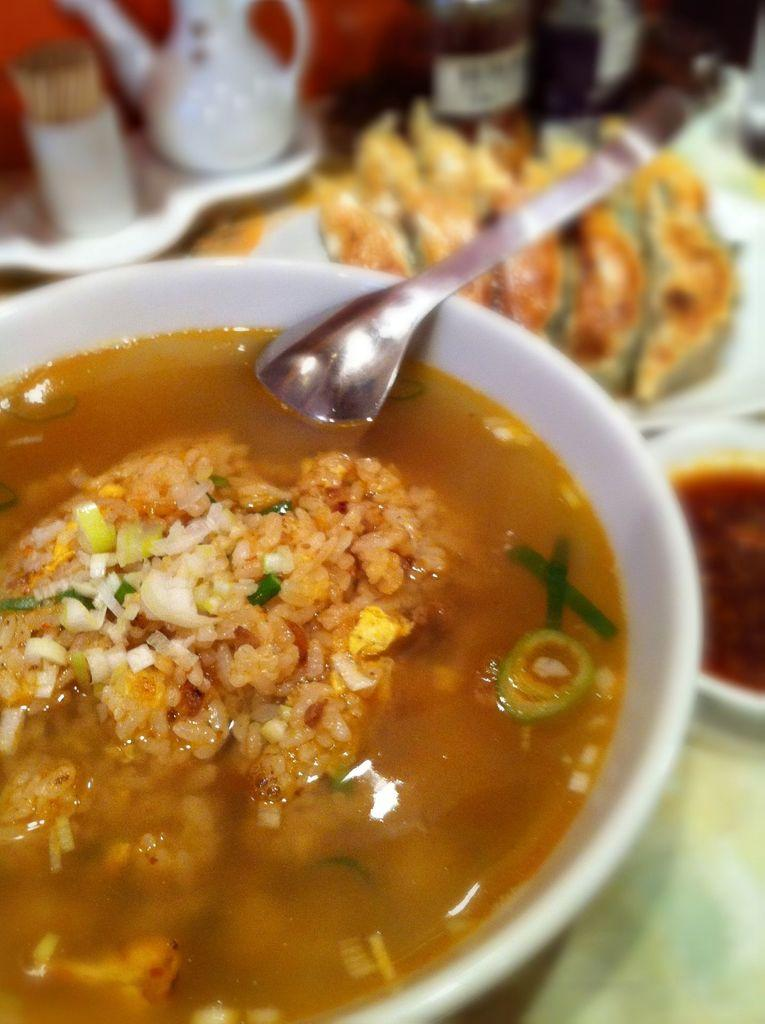What is in the bowl that is visible in the image? There is a bowl with food in the image. What utensil is present in the image? There is a spoon in the image. Can you describe the background of the image? There are objects visible in the background of the image. What type of bead is the girl wearing in the image? There is no girl present in the image, and therefore no bead or girl to describe. 